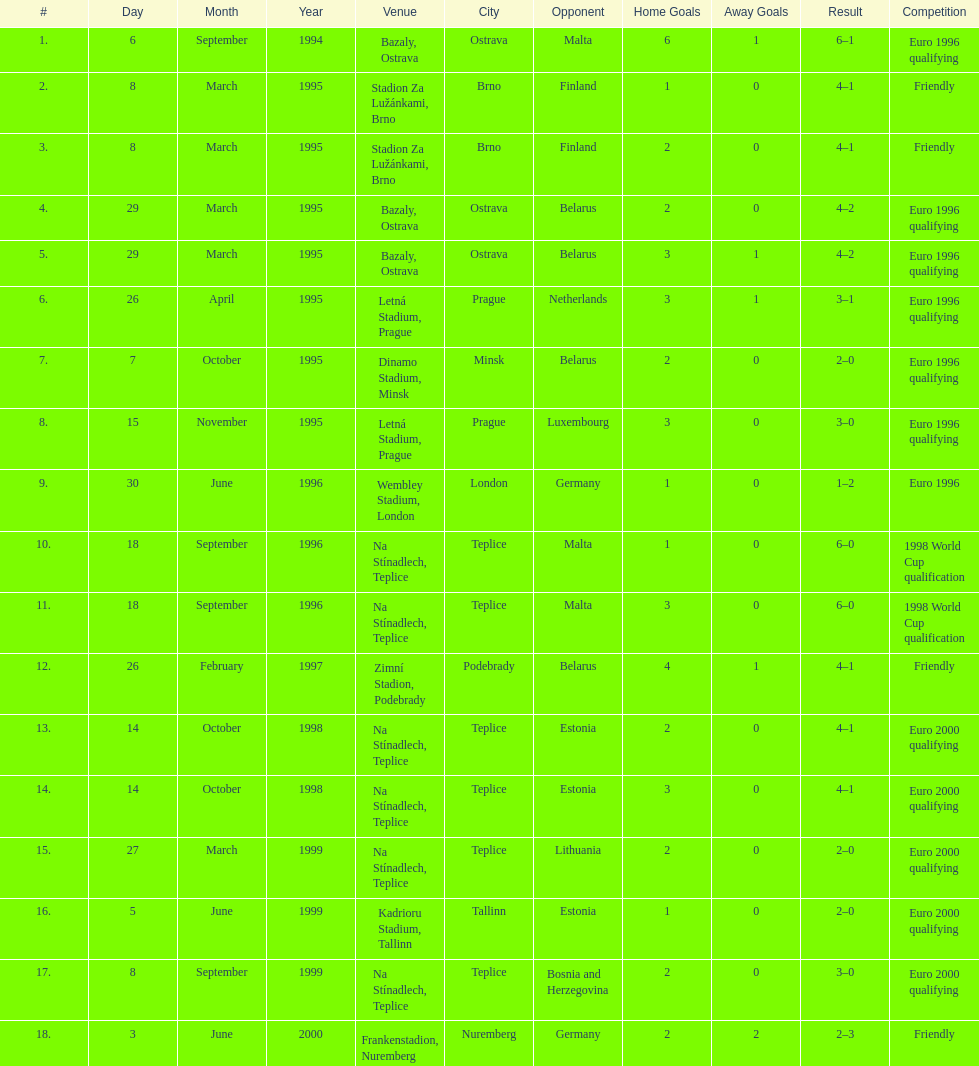List the opponent in which the result was the least out of all the results. Germany. 